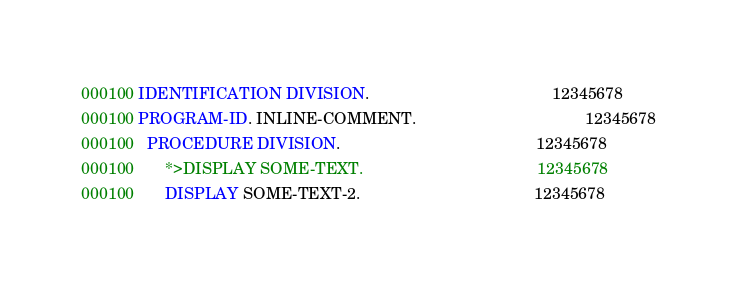Convert code to text. <code><loc_0><loc_0><loc_500><loc_500><_COBOL_>000100 IDENTIFICATION DIVISION.                                         12345678
000100 PROGRAM-ID. INLINE-COMMENT.                                      12345678
000100   PROCEDURE DIVISION.                                            12345678
000100       *>DISPLAY SOME-TEXT.                                       12345678
000100       DISPLAY SOME-TEXT-2.                                       12345678</code> 